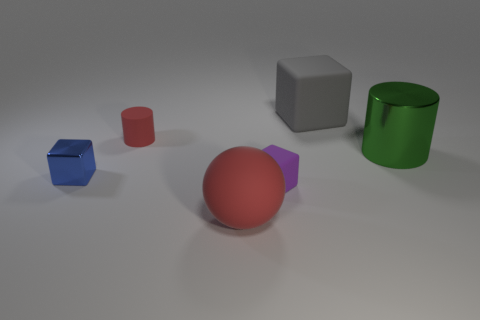Subtract all rubber cubes. How many cubes are left? 1 Subtract all purple blocks. How many blocks are left? 2 Subtract 0 red blocks. How many objects are left? 6 Subtract all balls. How many objects are left? 5 Subtract 2 cubes. How many cubes are left? 1 Subtract all brown spheres. Subtract all cyan cubes. How many spheres are left? 1 Subtract all cyan blocks. How many green spheres are left? 0 Subtract all big yellow metallic balls. Subtract all big metallic cylinders. How many objects are left? 5 Add 6 big things. How many big things are left? 9 Add 2 big spheres. How many big spheres exist? 3 